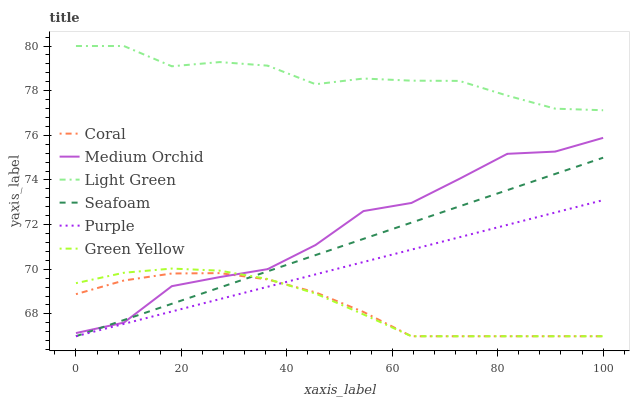Does Coral have the minimum area under the curve?
Answer yes or no. Yes. Does Light Green have the maximum area under the curve?
Answer yes or no. Yes. Does Medium Orchid have the minimum area under the curve?
Answer yes or no. No. Does Medium Orchid have the maximum area under the curve?
Answer yes or no. No. Is Seafoam the smoothest?
Answer yes or no. Yes. Is Medium Orchid the roughest?
Answer yes or no. Yes. Is Coral the smoothest?
Answer yes or no. No. Is Coral the roughest?
Answer yes or no. No. Does Purple have the lowest value?
Answer yes or no. Yes. Does Medium Orchid have the lowest value?
Answer yes or no. No. Does Light Green have the highest value?
Answer yes or no. Yes. Does Medium Orchid have the highest value?
Answer yes or no. No. Is Medium Orchid less than Light Green?
Answer yes or no. Yes. Is Medium Orchid greater than Purple?
Answer yes or no. Yes. Does Purple intersect Coral?
Answer yes or no. Yes. Is Purple less than Coral?
Answer yes or no. No. Is Purple greater than Coral?
Answer yes or no. No. Does Medium Orchid intersect Light Green?
Answer yes or no. No. 